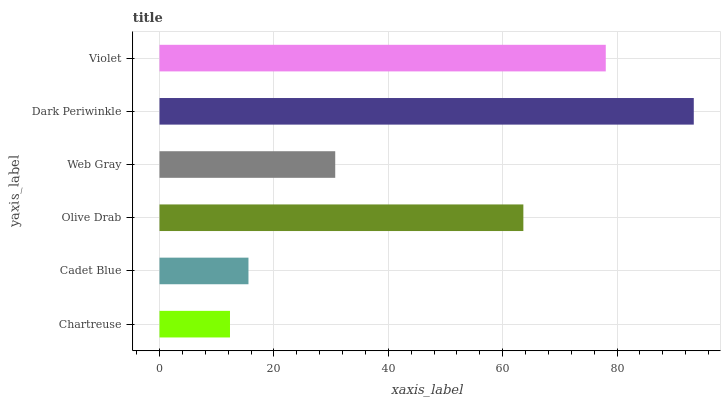Is Chartreuse the minimum?
Answer yes or no. Yes. Is Dark Periwinkle the maximum?
Answer yes or no. Yes. Is Cadet Blue the minimum?
Answer yes or no. No. Is Cadet Blue the maximum?
Answer yes or no. No. Is Cadet Blue greater than Chartreuse?
Answer yes or no. Yes. Is Chartreuse less than Cadet Blue?
Answer yes or no. Yes. Is Chartreuse greater than Cadet Blue?
Answer yes or no. No. Is Cadet Blue less than Chartreuse?
Answer yes or no. No. Is Olive Drab the high median?
Answer yes or no. Yes. Is Web Gray the low median?
Answer yes or no. Yes. Is Web Gray the high median?
Answer yes or no. No. Is Chartreuse the low median?
Answer yes or no. No. 